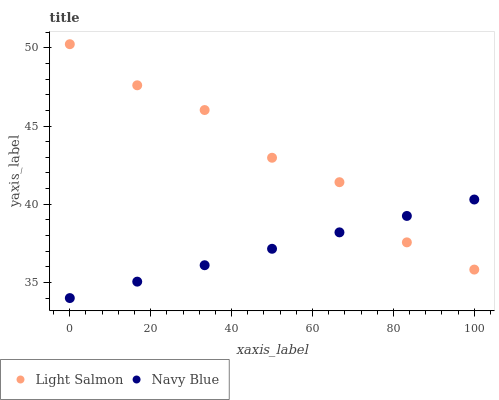Does Navy Blue have the minimum area under the curve?
Answer yes or no. Yes. Does Light Salmon have the maximum area under the curve?
Answer yes or no. Yes. Does Light Salmon have the minimum area under the curve?
Answer yes or no. No. Is Navy Blue the smoothest?
Answer yes or no. Yes. Is Light Salmon the roughest?
Answer yes or no. Yes. Is Light Salmon the smoothest?
Answer yes or no. No. Does Navy Blue have the lowest value?
Answer yes or no. Yes. Does Light Salmon have the lowest value?
Answer yes or no. No. Does Light Salmon have the highest value?
Answer yes or no. Yes. Does Navy Blue intersect Light Salmon?
Answer yes or no. Yes. Is Navy Blue less than Light Salmon?
Answer yes or no. No. Is Navy Blue greater than Light Salmon?
Answer yes or no. No. 